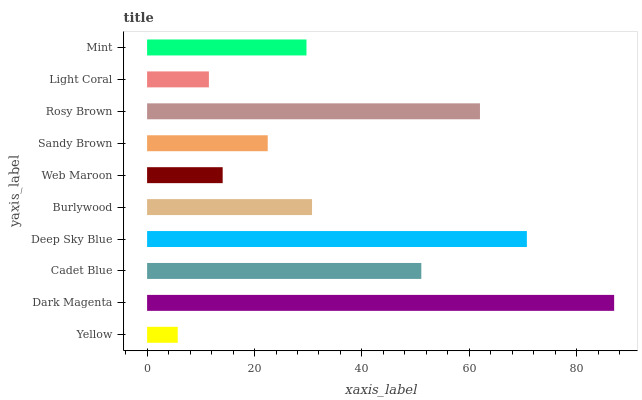Is Yellow the minimum?
Answer yes or no. Yes. Is Dark Magenta the maximum?
Answer yes or no. Yes. Is Cadet Blue the minimum?
Answer yes or no. No. Is Cadet Blue the maximum?
Answer yes or no. No. Is Dark Magenta greater than Cadet Blue?
Answer yes or no. Yes. Is Cadet Blue less than Dark Magenta?
Answer yes or no. Yes. Is Cadet Blue greater than Dark Magenta?
Answer yes or no. No. Is Dark Magenta less than Cadet Blue?
Answer yes or no. No. Is Burlywood the high median?
Answer yes or no. Yes. Is Mint the low median?
Answer yes or no. Yes. Is Light Coral the high median?
Answer yes or no. No. Is Yellow the low median?
Answer yes or no. No. 